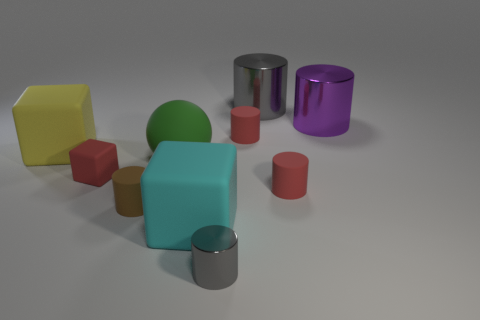Is there a rubber cylinder of the same color as the tiny metal cylinder?
Keep it short and to the point. No. What number of balls are small green rubber objects or big cyan objects?
Your answer should be very brief. 0. Are there any small brown things that have the same shape as the large gray thing?
Keep it short and to the point. Yes. How many other things are the same color as the big matte sphere?
Keep it short and to the point. 0. Is the number of tiny blocks behind the purple thing less than the number of red things?
Ensure brevity in your answer.  Yes. What number of big yellow shiny cubes are there?
Offer a terse response. 0. How many things have the same material as the big yellow block?
Provide a short and direct response. 6. How many things are either big things that are behind the tiny brown matte object or yellow blocks?
Keep it short and to the point. 4. Are there fewer small cylinders on the right side of the matte sphere than big gray objects on the left side of the brown matte cylinder?
Give a very brief answer. No. Are there any red rubber blocks behind the large green ball?
Provide a succinct answer. No. 